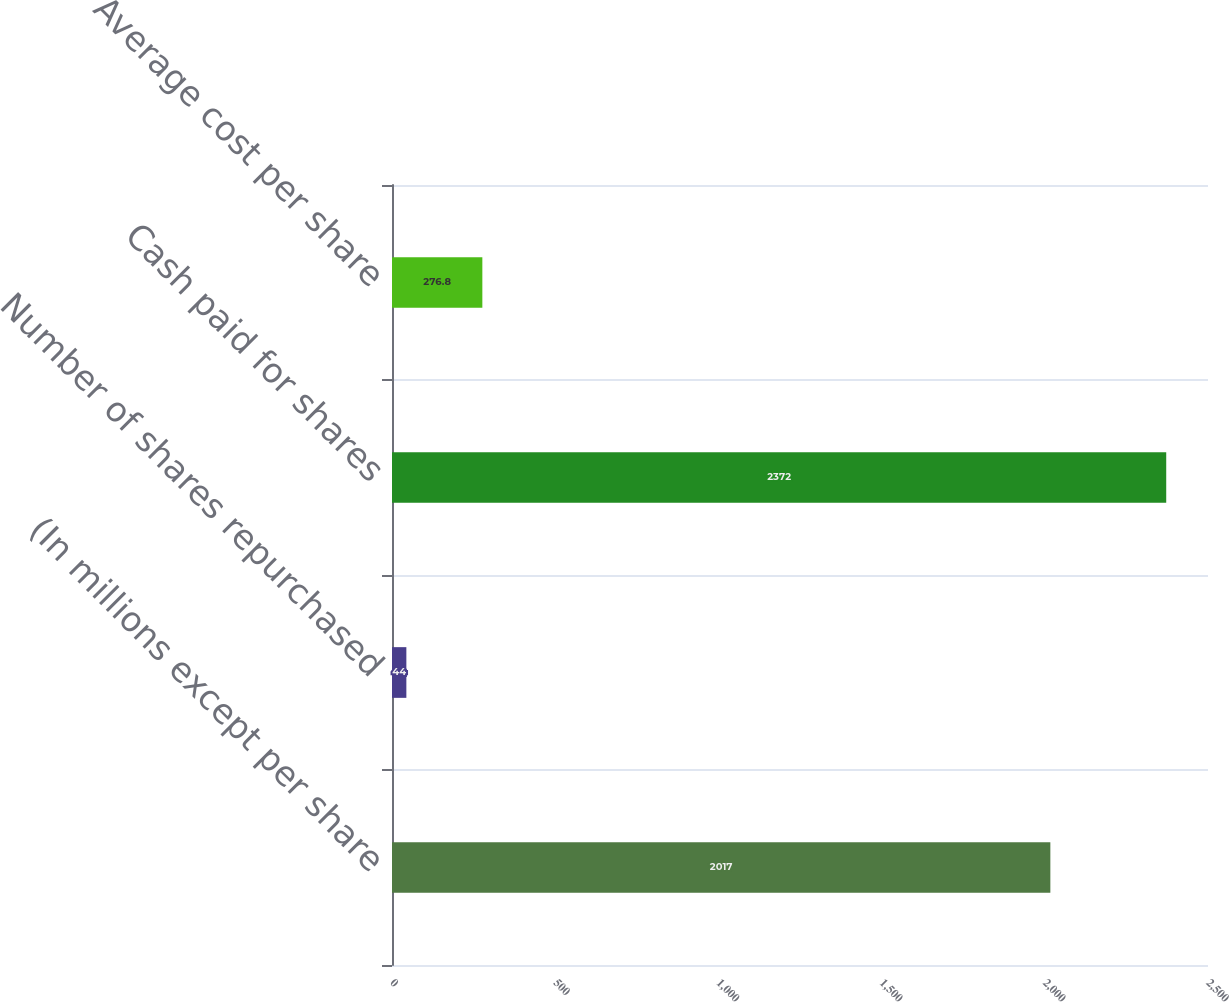Convert chart. <chart><loc_0><loc_0><loc_500><loc_500><bar_chart><fcel>(In millions except per share<fcel>Number of shares repurchased<fcel>Cash paid for shares<fcel>Average cost per share<nl><fcel>2017<fcel>44<fcel>2372<fcel>276.8<nl></chart> 